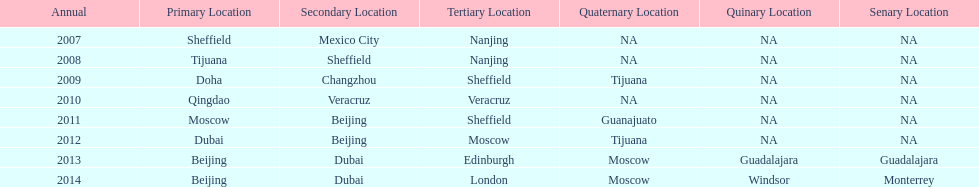How long, in years, has the this world series been occurring? 7 years. 